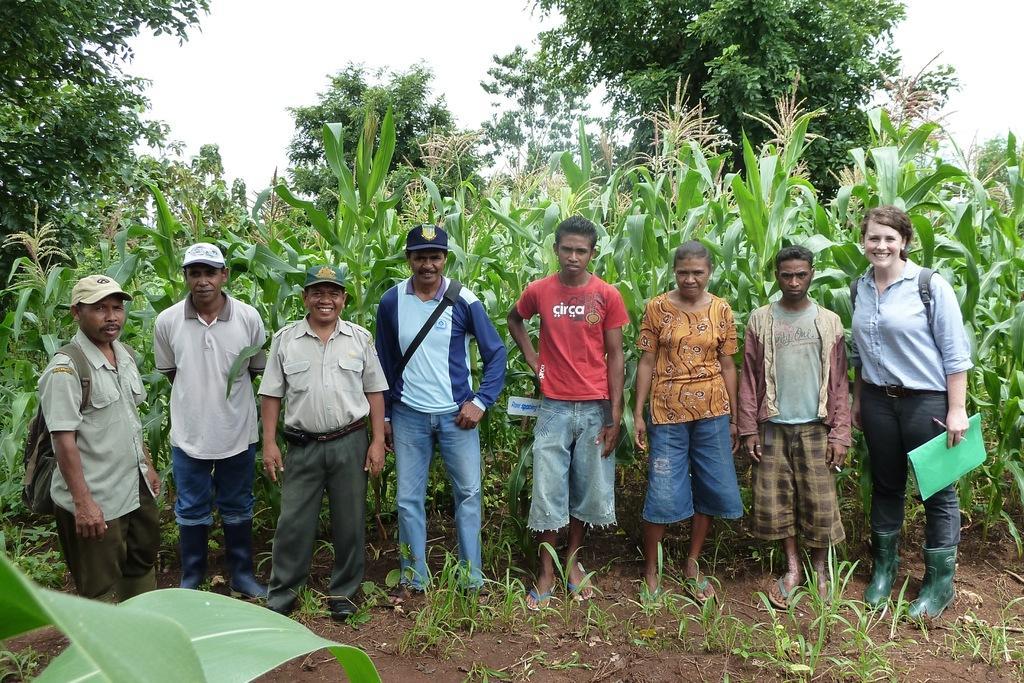Could you give a brief overview of what you see in this image? In this image in the center there are some people standing, and some of them are wearing bags and one person is holding a book and pen. And at the bottom there is sand and some plants, in the background there are plants and trees. At the top there is sky. 